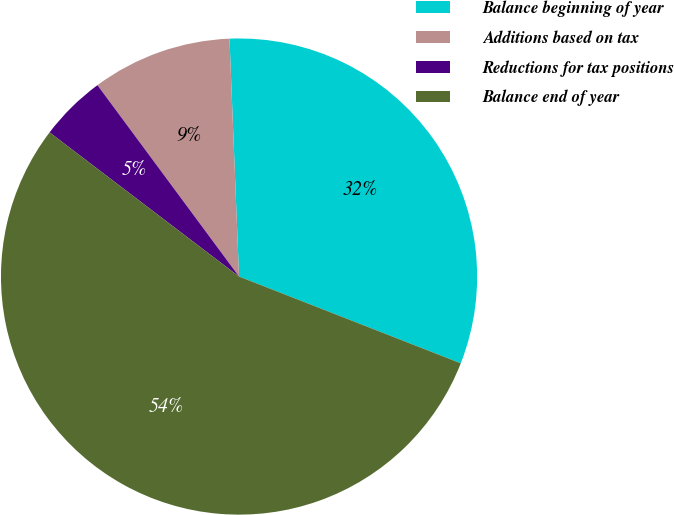Convert chart. <chart><loc_0><loc_0><loc_500><loc_500><pie_chart><fcel>Balance beginning of year<fcel>Additions based on tax<fcel>Reductions for tax positions<fcel>Balance end of year<nl><fcel>31.58%<fcel>9.5%<fcel>4.51%<fcel>54.42%<nl></chart> 